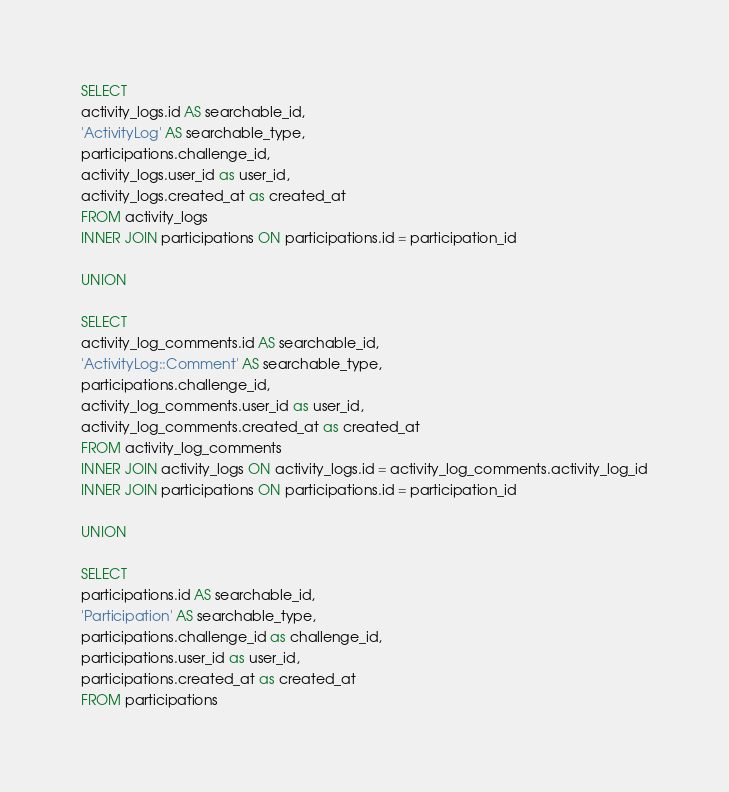<code> <loc_0><loc_0><loc_500><loc_500><_SQL_>SELECT
activity_logs.id AS searchable_id,
'ActivityLog' AS searchable_type,
participations.challenge_id,
activity_logs.user_id as user_id,
activity_logs.created_at as created_at
FROM activity_logs
INNER JOIN participations ON participations.id = participation_id

UNION

SELECT
activity_log_comments.id AS searchable_id,
'ActivityLog::Comment' AS searchable_type,
participations.challenge_id,
activity_log_comments.user_id as user_id,
activity_log_comments.created_at as created_at
FROM activity_log_comments
INNER JOIN activity_logs ON activity_logs.id = activity_log_comments.activity_log_id
INNER JOIN participations ON participations.id = participation_id

UNION

SELECT
participations.id AS searchable_id,
'Participation' AS searchable_type,
participations.challenge_id as challenge_id,
participations.user_id as user_id,
participations.created_at as created_at
FROM participations

</code> 